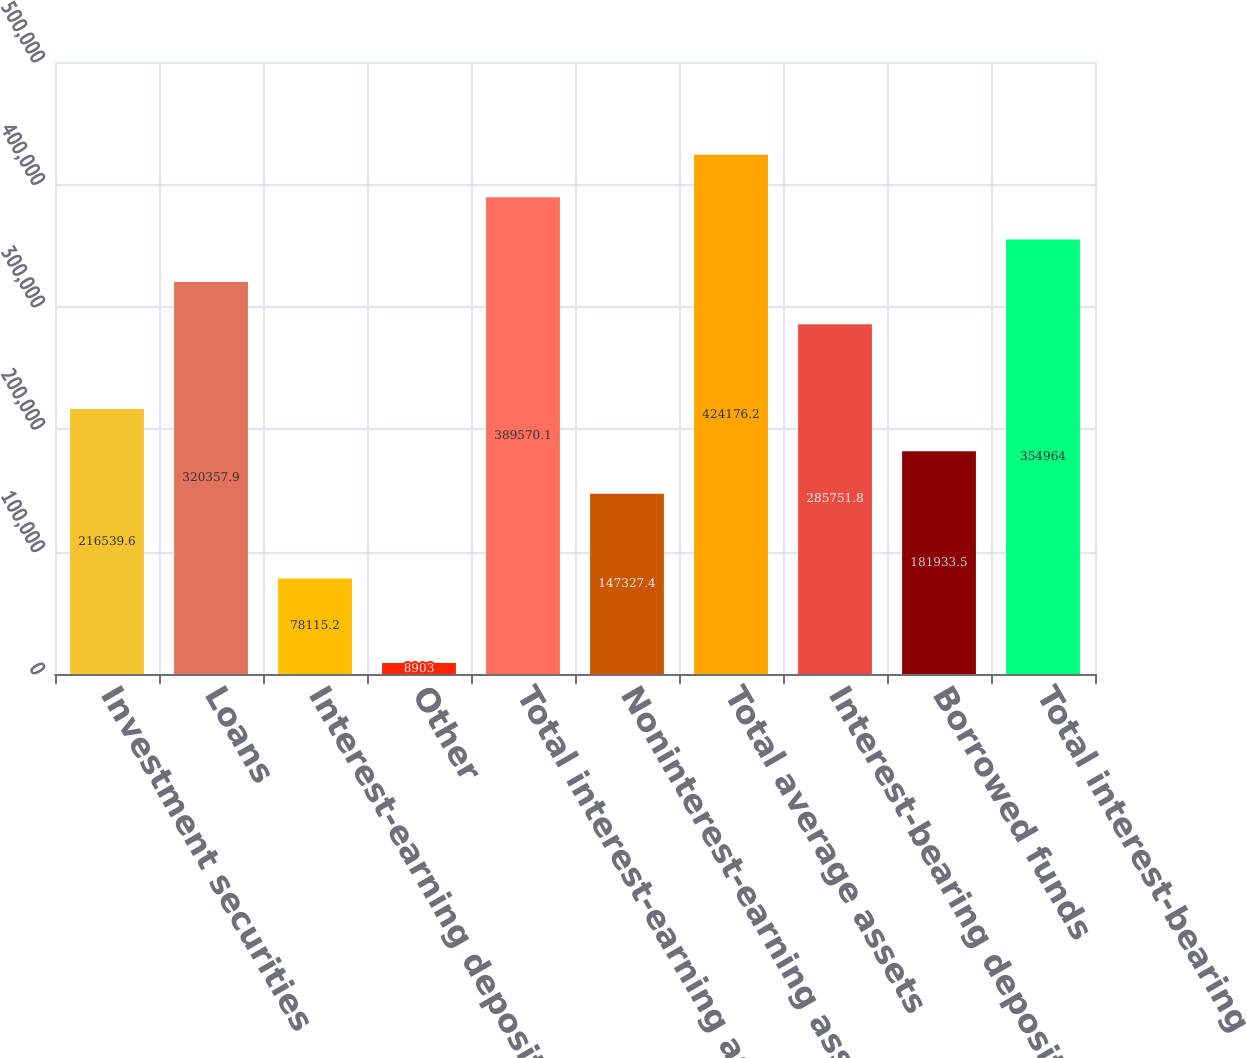Convert chart to OTSL. <chart><loc_0><loc_0><loc_500><loc_500><bar_chart><fcel>Investment securities<fcel>Loans<fcel>Interest-earning deposits with<fcel>Other<fcel>Total interest-earning assets<fcel>Noninterest-earning assets<fcel>Total average assets<fcel>Interest-bearing deposits<fcel>Borrowed funds<fcel>Total interest-bearing<nl><fcel>216540<fcel>320358<fcel>78115.2<fcel>8903<fcel>389570<fcel>147327<fcel>424176<fcel>285752<fcel>181934<fcel>354964<nl></chart> 